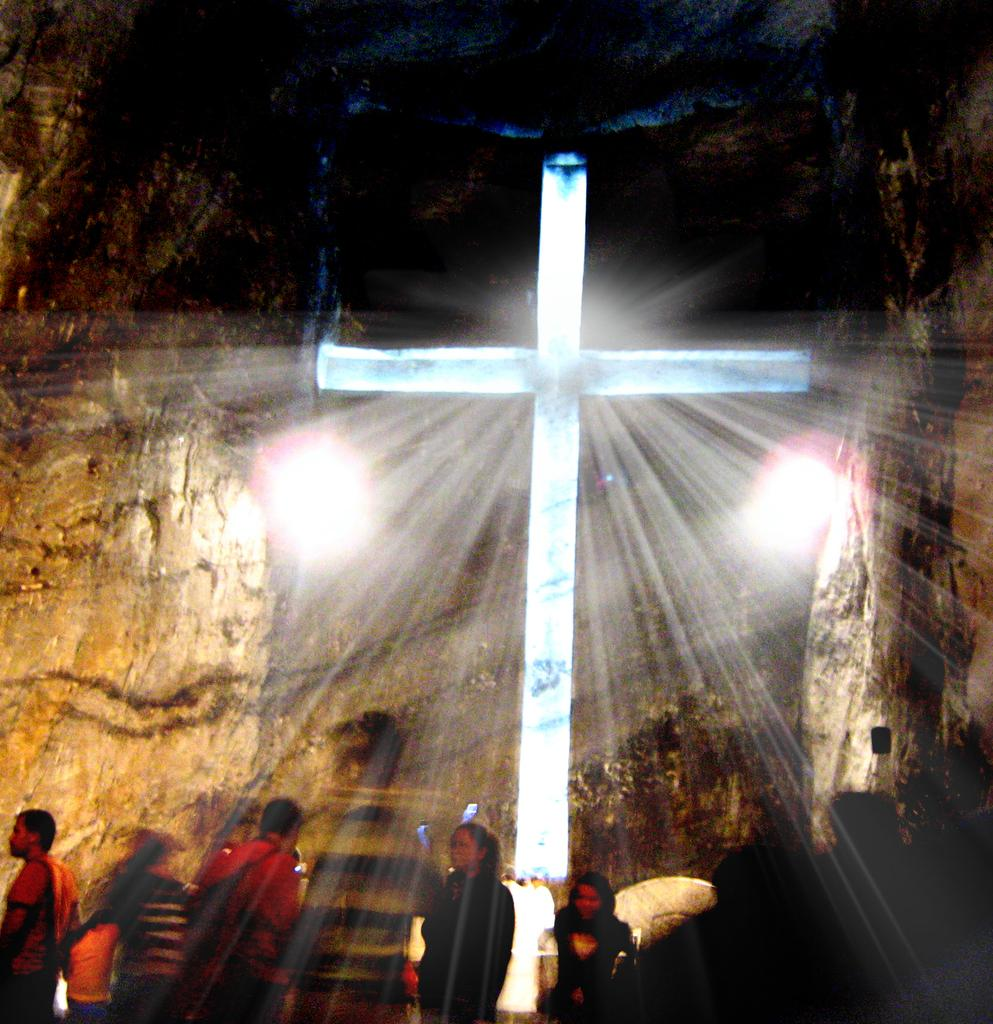What type of location is depicted in the image? The image shows the interior view of a cave. What religious symbol can be seen in the image? There is a Christian cross in the image. Are there any people present in the image? Yes, there are a few people in the image. What can be used to illuminate the cave in the image? There are lights visible in the image. What else can be seen in the image besides the people and the cross? There are objects present in the image. What type of debt can be seen in the image? There is no debt present in the image; it depicts the interior of a cave with a Christian cross, people, lights, and objects. What type of clouds can be seen in the image? There are no clouds present in the image, as it shows the interior of a cave. 